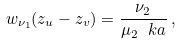Convert formula to latex. <formula><loc_0><loc_0><loc_500><loc_500>w _ { \nu _ { 1 } } ( z _ { u } - z _ { v } ) = \frac { \nu _ { 2 } } { \mu _ { 2 } \, \ k a } \, ,</formula> 